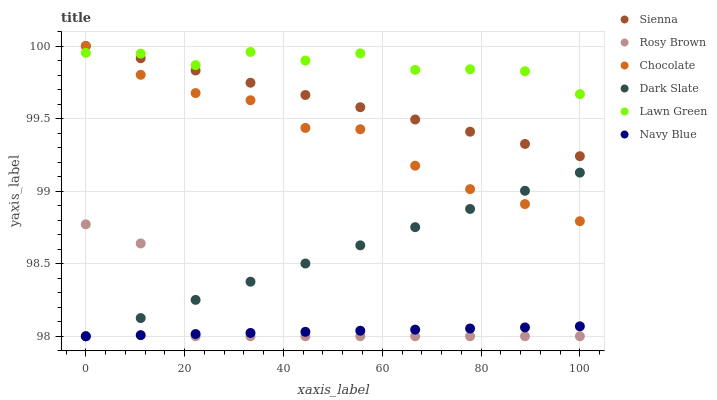Does Navy Blue have the minimum area under the curve?
Answer yes or no. Yes. Does Lawn Green have the maximum area under the curve?
Answer yes or no. Yes. Does Rosy Brown have the minimum area under the curve?
Answer yes or no. No. Does Rosy Brown have the maximum area under the curve?
Answer yes or no. No. Is Navy Blue the smoothest?
Answer yes or no. Yes. Is Rosy Brown the roughest?
Answer yes or no. Yes. Is Rosy Brown the smoothest?
Answer yes or no. No. Is Navy Blue the roughest?
Answer yes or no. No. Does Navy Blue have the lowest value?
Answer yes or no. Yes. Does Chocolate have the lowest value?
Answer yes or no. No. Does Sienna have the highest value?
Answer yes or no. Yes. Does Rosy Brown have the highest value?
Answer yes or no. No. Is Rosy Brown less than Lawn Green?
Answer yes or no. Yes. Is Sienna greater than Rosy Brown?
Answer yes or no. Yes. Does Chocolate intersect Dark Slate?
Answer yes or no. Yes. Is Chocolate less than Dark Slate?
Answer yes or no. No. Is Chocolate greater than Dark Slate?
Answer yes or no. No. Does Rosy Brown intersect Lawn Green?
Answer yes or no. No. 